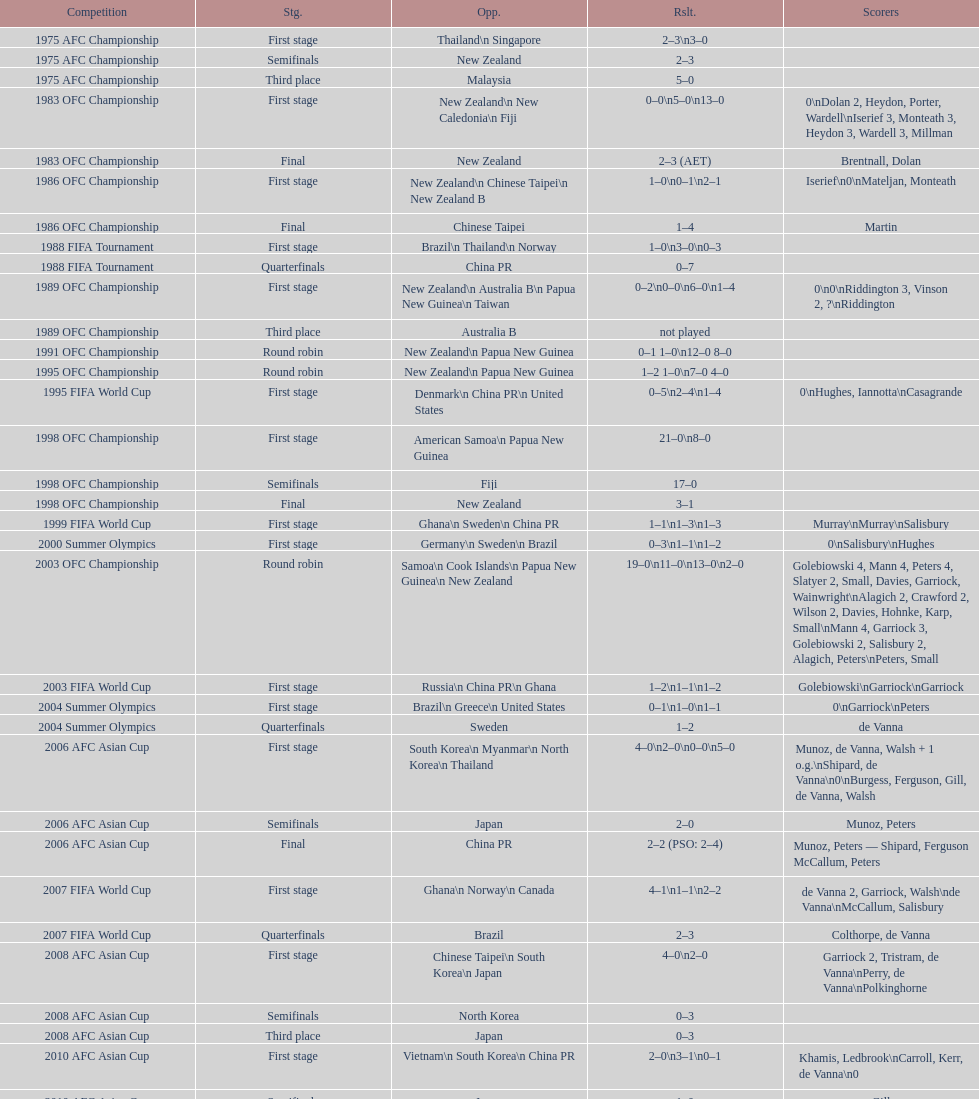How many stages were round robins? 3. 